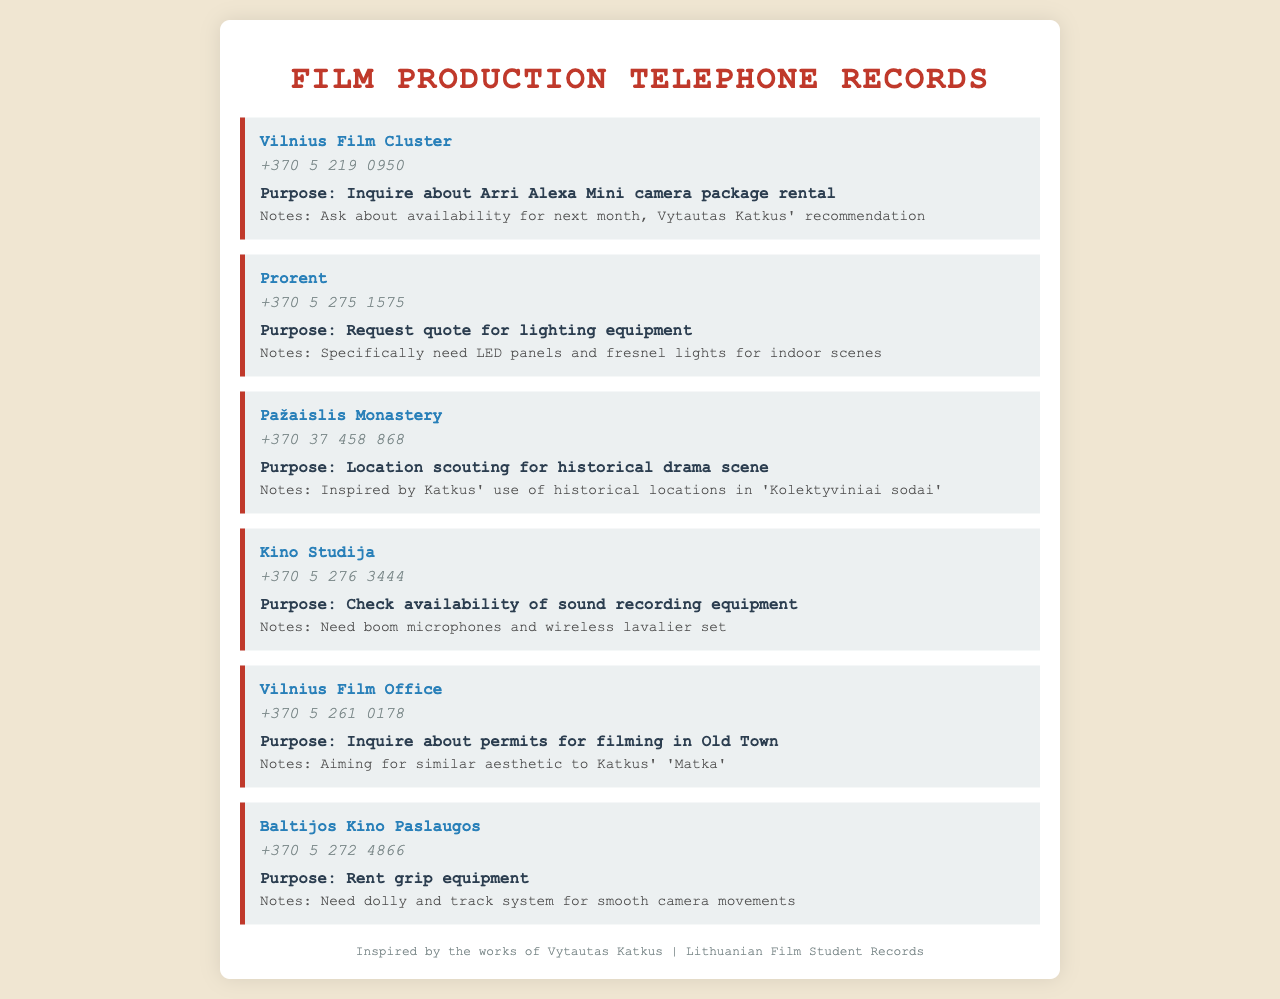What is the phone number for Vilnius Film Cluster? The phone number is listed directly under the company name in the document.
Answer: +370 5 219 0950 What equipment is requested from Prorent? The request details what specific lighting equipment is being sought by the film student.
Answer: Quote for lighting equipment Which location is being scouted for a historical drama scene? The document specifies the company and the intended purpose for location scouting.
Answer: Pažaislis Monastery What type of sound equipment is checked with Kino Studija? The specific type of equipment sought is explicitly mentioned in the call record.
Answer: Boom microphones and wireless lavalier set Which film inspired the inquiry about permits from Vilnius Film Office? The notes highlight a film that influenced the aesthetic being pursued in the filming.
Answer: Matka What is being rented from Baltijos Kino Paslaugos? The call record states the specific type of equipment being rented through this service.
Answer: Grip equipment 